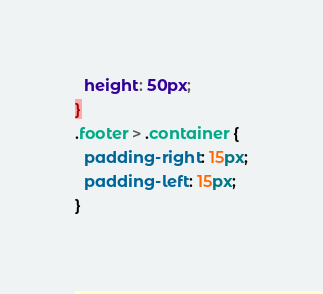<code> <loc_0><loc_0><loc_500><loc_500><_CSS_>  height: 50px;
}
.footer > .container {
  padding-right: 15px;
  padding-left: 15px;
}</code> 